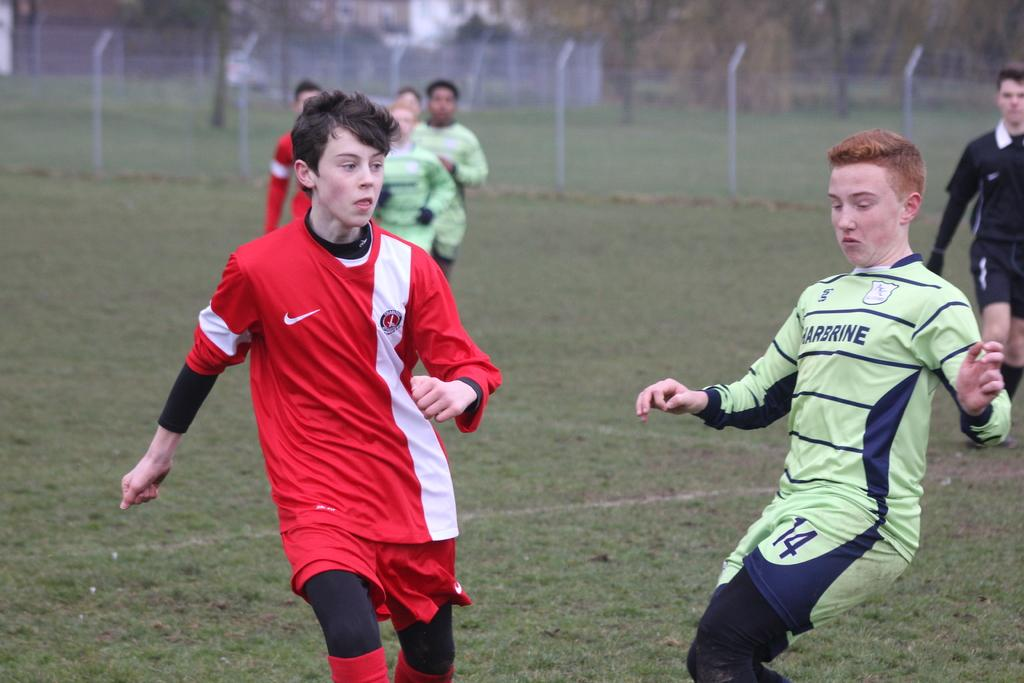Provide a one-sentence caption for the provided image. A soccer game with one team in red uniforms and the other in light green Harbrine uniforms. 